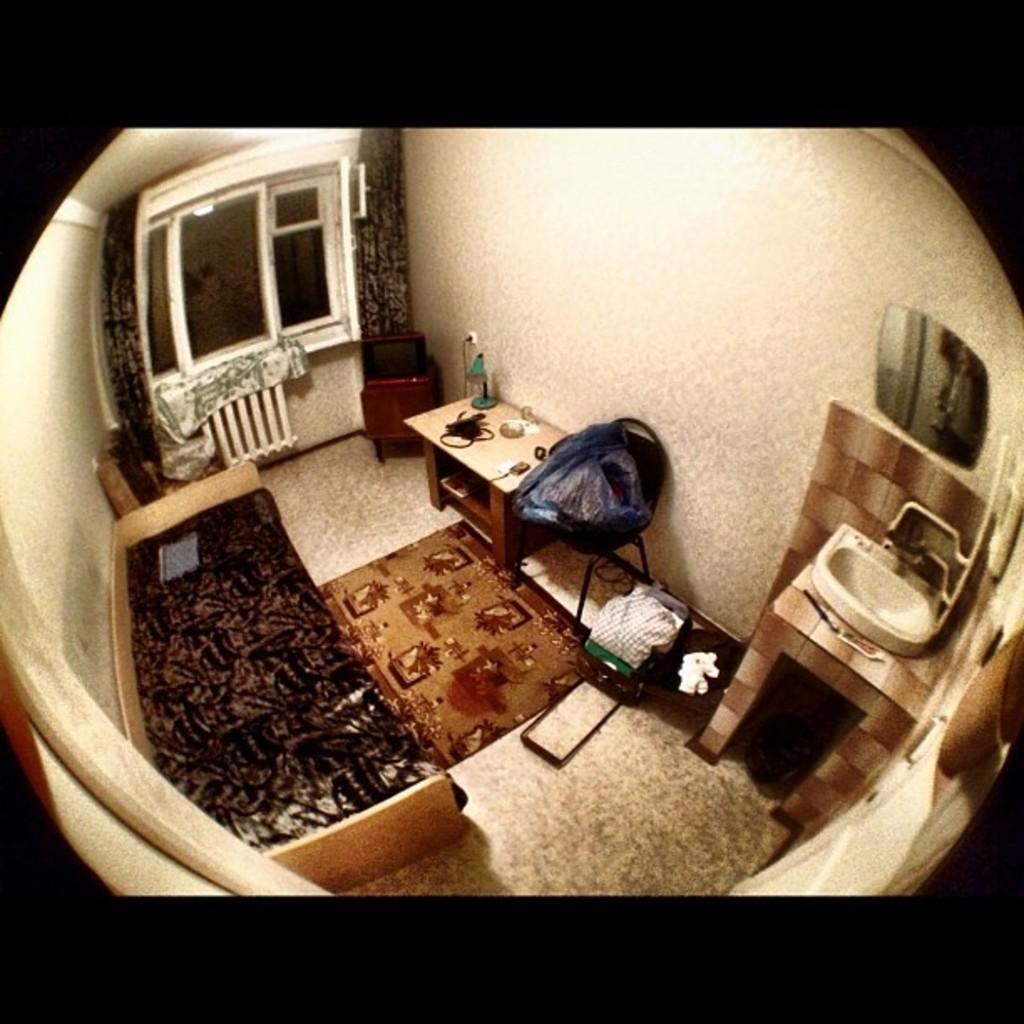Describe this image in one or two sentences. Inside the room there is a bed, table with a few items, bag, sink, mirror, floor mat, windows and curtains, television and some other items. 